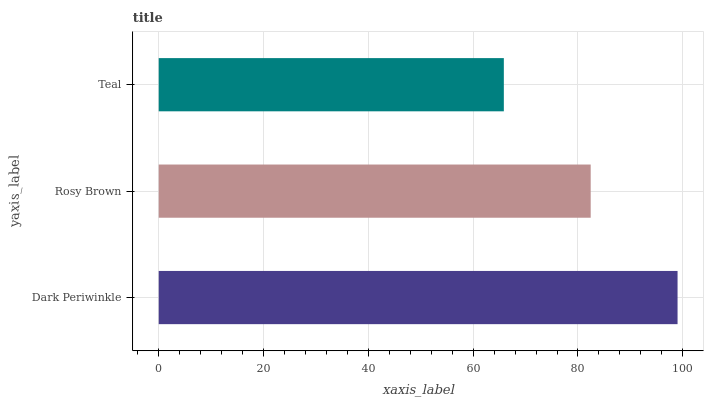Is Teal the minimum?
Answer yes or no. Yes. Is Dark Periwinkle the maximum?
Answer yes or no. Yes. Is Rosy Brown the minimum?
Answer yes or no. No. Is Rosy Brown the maximum?
Answer yes or no. No. Is Dark Periwinkle greater than Rosy Brown?
Answer yes or no. Yes. Is Rosy Brown less than Dark Periwinkle?
Answer yes or no. Yes. Is Rosy Brown greater than Dark Periwinkle?
Answer yes or no. No. Is Dark Periwinkle less than Rosy Brown?
Answer yes or no. No. Is Rosy Brown the high median?
Answer yes or no. Yes. Is Rosy Brown the low median?
Answer yes or no. Yes. Is Teal the high median?
Answer yes or no. No. Is Dark Periwinkle the low median?
Answer yes or no. No. 